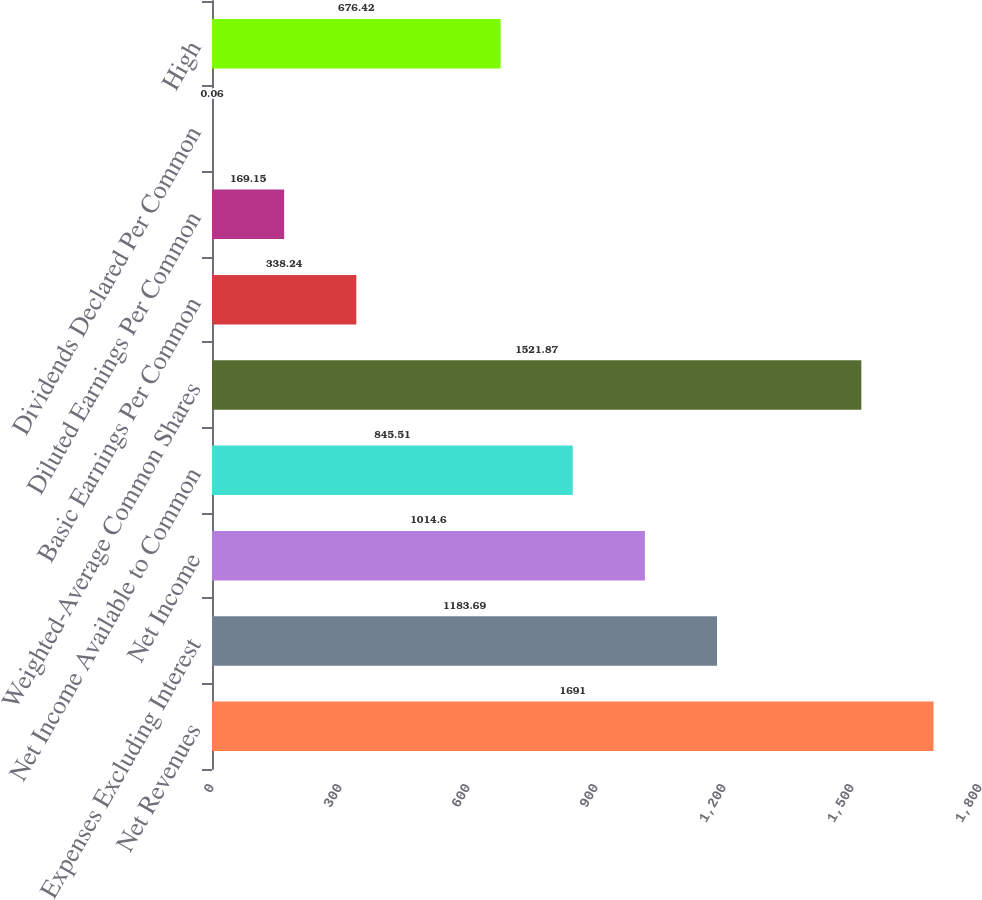Convert chart to OTSL. <chart><loc_0><loc_0><loc_500><loc_500><bar_chart><fcel>Net Revenues<fcel>Expenses Excluding Interest<fcel>Net Income<fcel>Net Income Available to Common<fcel>Weighted-Average Common Shares<fcel>Basic Earnings Per Common<fcel>Diluted Earnings Per Common<fcel>Dividends Declared Per Common<fcel>High<nl><fcel>1691<fcel>1183.69<fcel>1014.6<fcel>845.51<fcel>1521.87<fcel>338.24<fcel>169.15<fcel>0.06<fcel>676.42<nl></chart> 